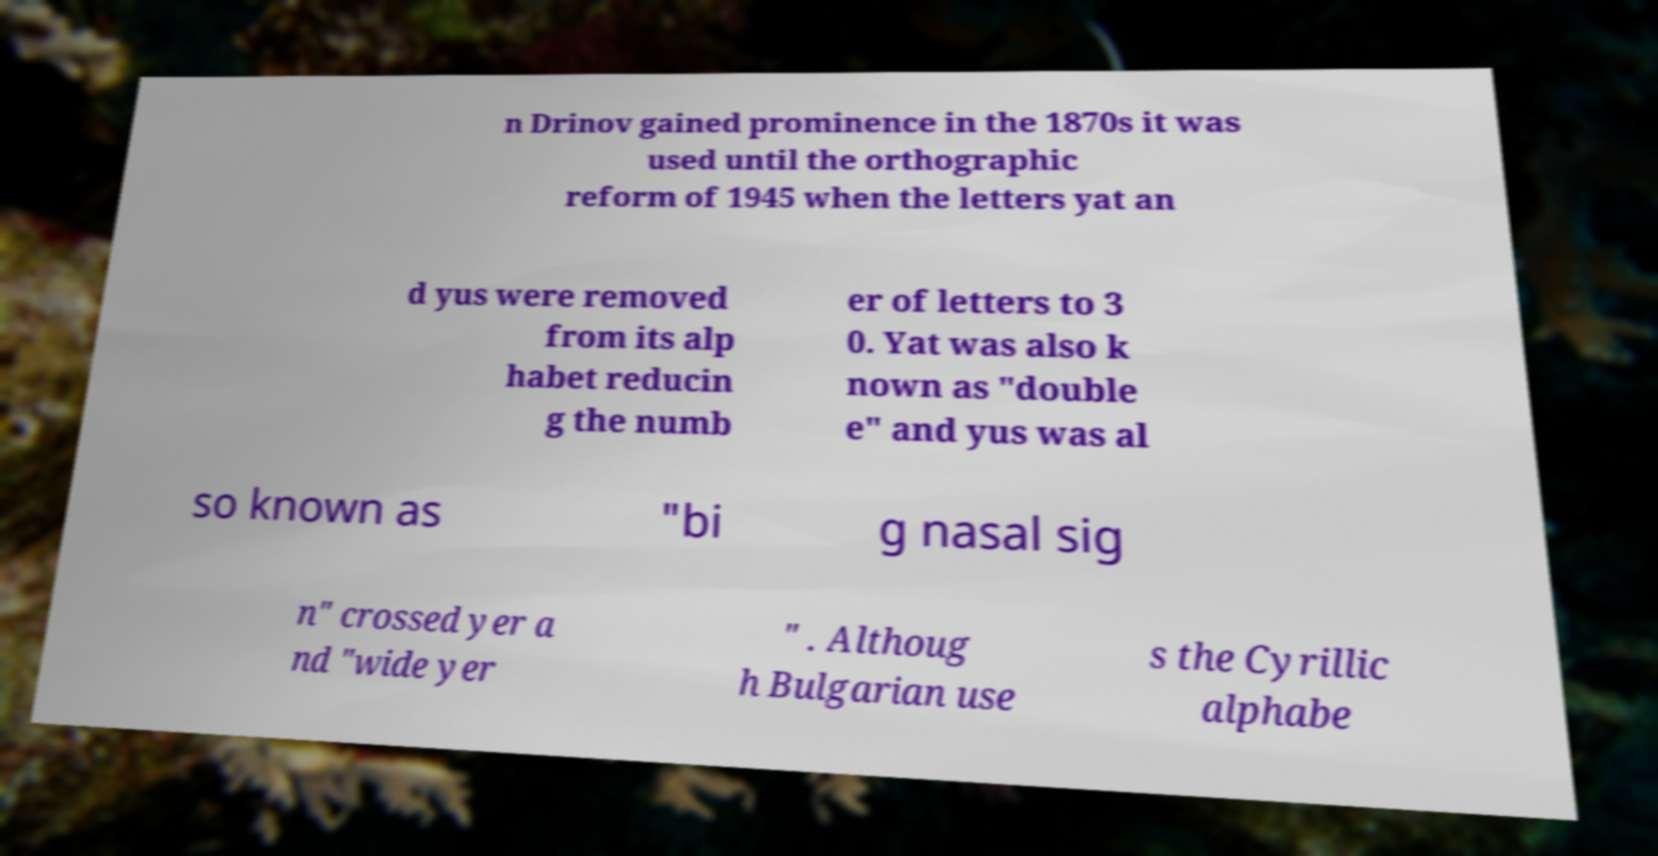I need the written content from this picture converted into text. Can you do that? n Drinov gained prominence in the 1870s it was used until the orthographic reform of 1945 when the letters yat an d yus were removed from its alp habet reducin g the numb er of letters to 3 0. Yat was also k nown as "double e" and yus was al so known as "bi g nasal sig n" crossed yer a nd "wide yer " . Althoug h Bulgarian use s the Cyrillic alphabe 